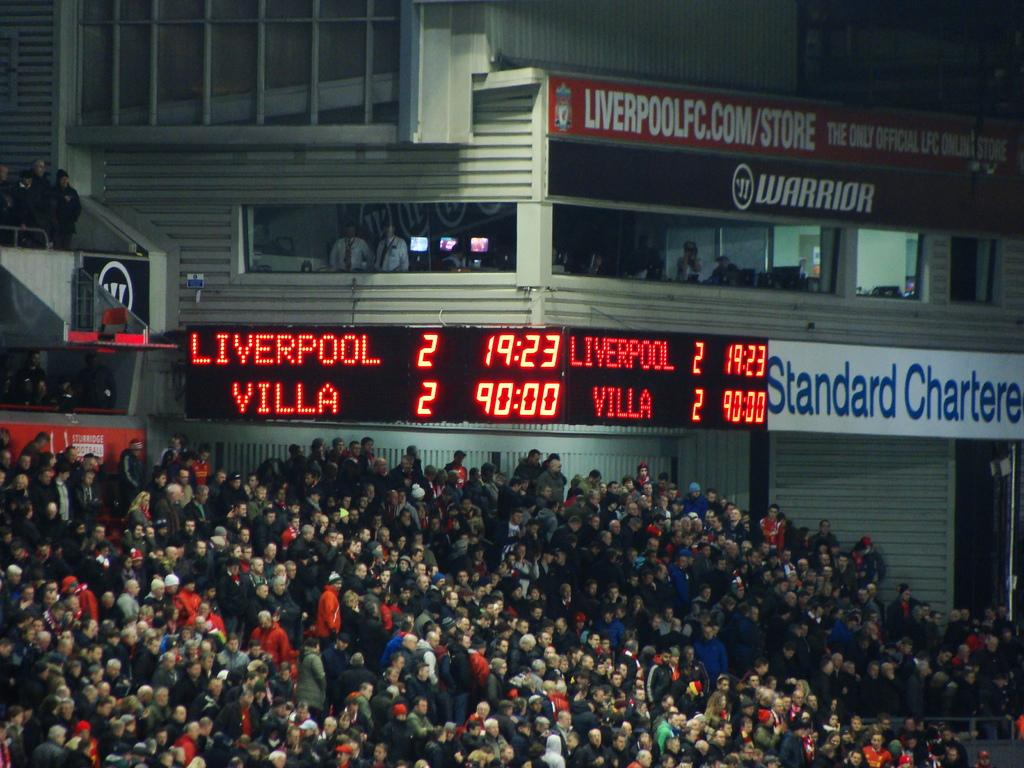<image>
Relay a brief, clear account of the picture shown. The scoreboard is showing a tied game between Liverpool and Villa. 